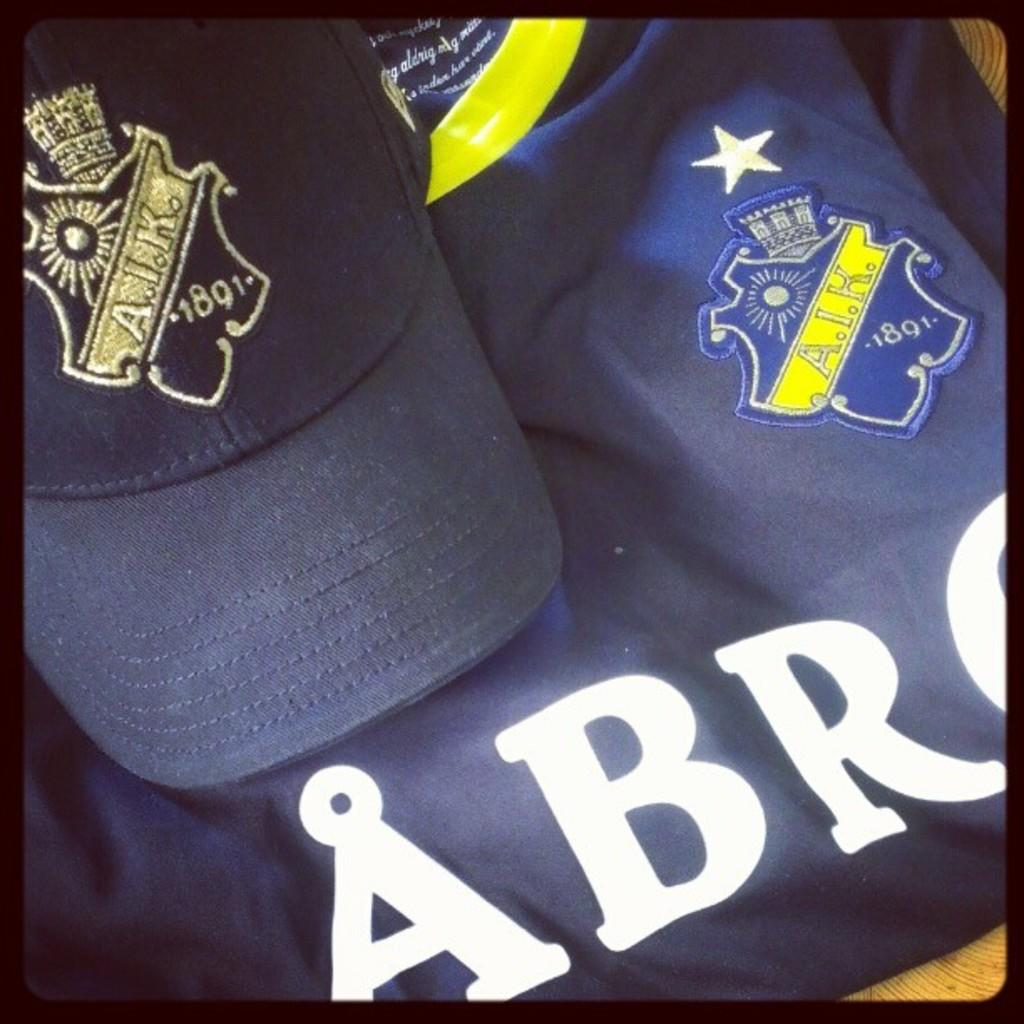What type of clothing item is in the image? There is a T-shirt in the image. What accessory is also present in the image? There is a cap in the image. Where are the cap and T-shirt located? The cap and T-shirt are on an object. What type of vegetable is being used as a coil in the image? There is no vegetable or coil present in the image. 